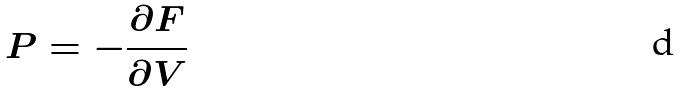<formula> <loc_0><loc_0><loc_500><loc_500>P = - \frac { \partial F } { \partial V }</formula> 